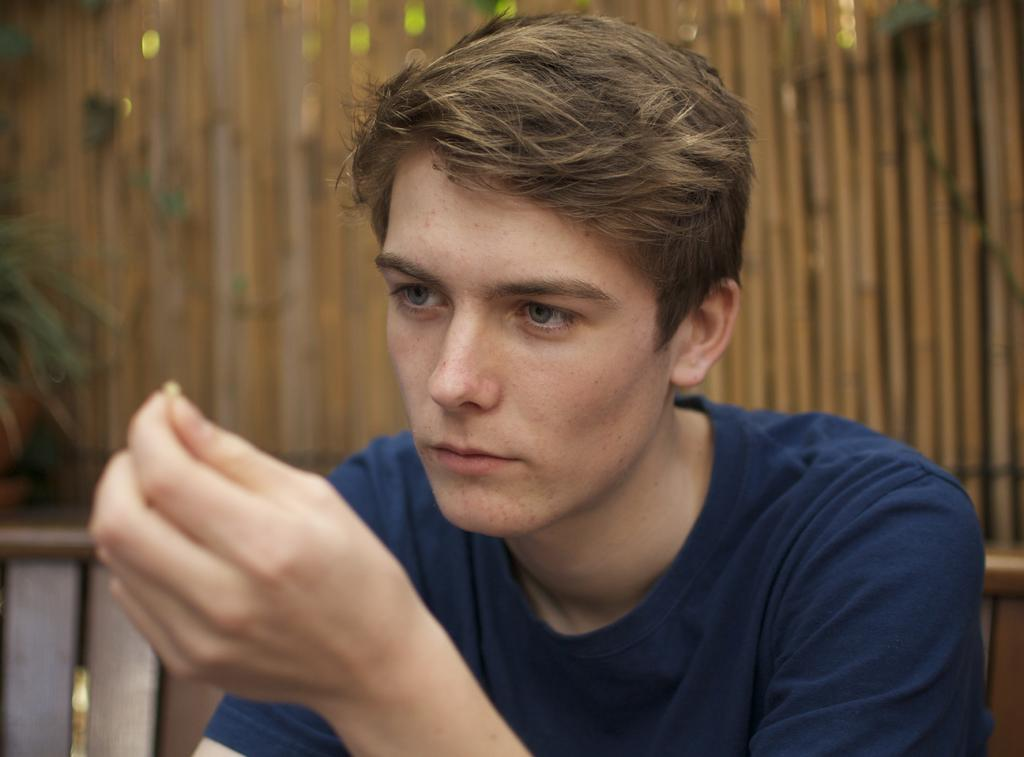What is the man in the image doing? The man is sitting on a chair in the image. What is the man holding in the image? The man is holding an object in the image. How many chairs are visible in the image? There are two chairs in the image. What is the material of the wall behind the man? The wall behind the man is made of wood. What type of vegetation is present in the image? There are green plants in the image. How many frogs are sitting on the man's wrist in the image? There are no frogs present in the image, and the man's wrist is not visible. 